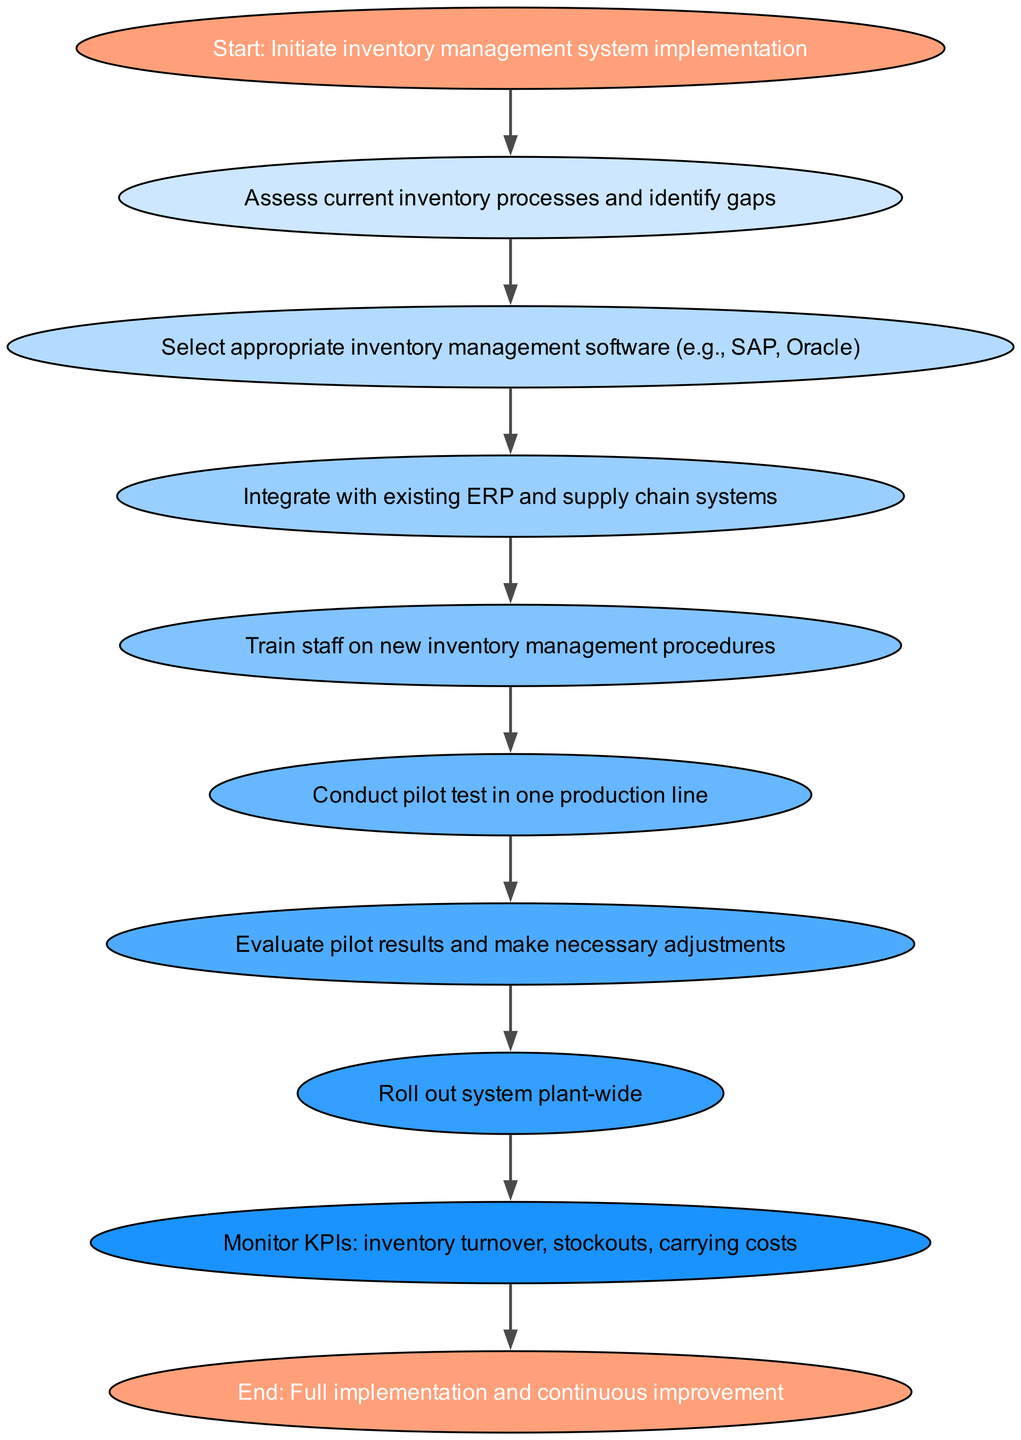What is the first step in the workflow? The first step in the workflow, as depicted in the diagram, is "Start: Initiate inventory management system implementation." This is represented as a node labeled "start," which is the entry point of the flowchart.
Answer: Start: Initiate inventory management system implementation How many steps are involved in the implementation process? By counting the nodes in the diagram, there are ten distinct steps represented, including the start and end nodes. Each step indicates a phase in the workflow for implementing the system.
Answer: 10 Which node follows the "Select appropriate inventory management software"? In the diagram, the node that immediately follows "Select appropriate inventory management software" is "Integrate with existing ERP and supply chain systems." This shows the progression from choosing software to integrating it into existing processes.
Answer: Integrate with existing ERP and supply chain systems What is the last step before the full implementation? The last step before full implementation, as shown in the flowchart, is "Monitor KPIs: inventory turnover, stockouts, carrying costs." This step occurs just prior to reaching the final state of full implementation and continuous improvement.
Answer: Monitor KPIs: inventory turnover, stockouts, carrying costs Which process is evaluated after the pilot test? According to the diagram, the process that is evaluated after conducting the pilot test is "Evaluate pilot results and make necessary adjustments." This indicates that assessment follows testing to refine the system before wider rollout.
Answer: Evaluate pilot results and make necessary adjustments What node comes before "Train staff on new inventory management procedures"? The node that comes immediately before "Train staff on new inventory management procedures" is "Integrate with existing ERP and supply chain systems." This signifies the order of operations leading up to staff training.
Answer: Integrate with existing ERP and supply chain systems 